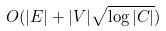<formula> <loc_0><loc_0><loc_500><loc_500>O ( | E | + | V | \sqrt { \log | C | } )</formula> 